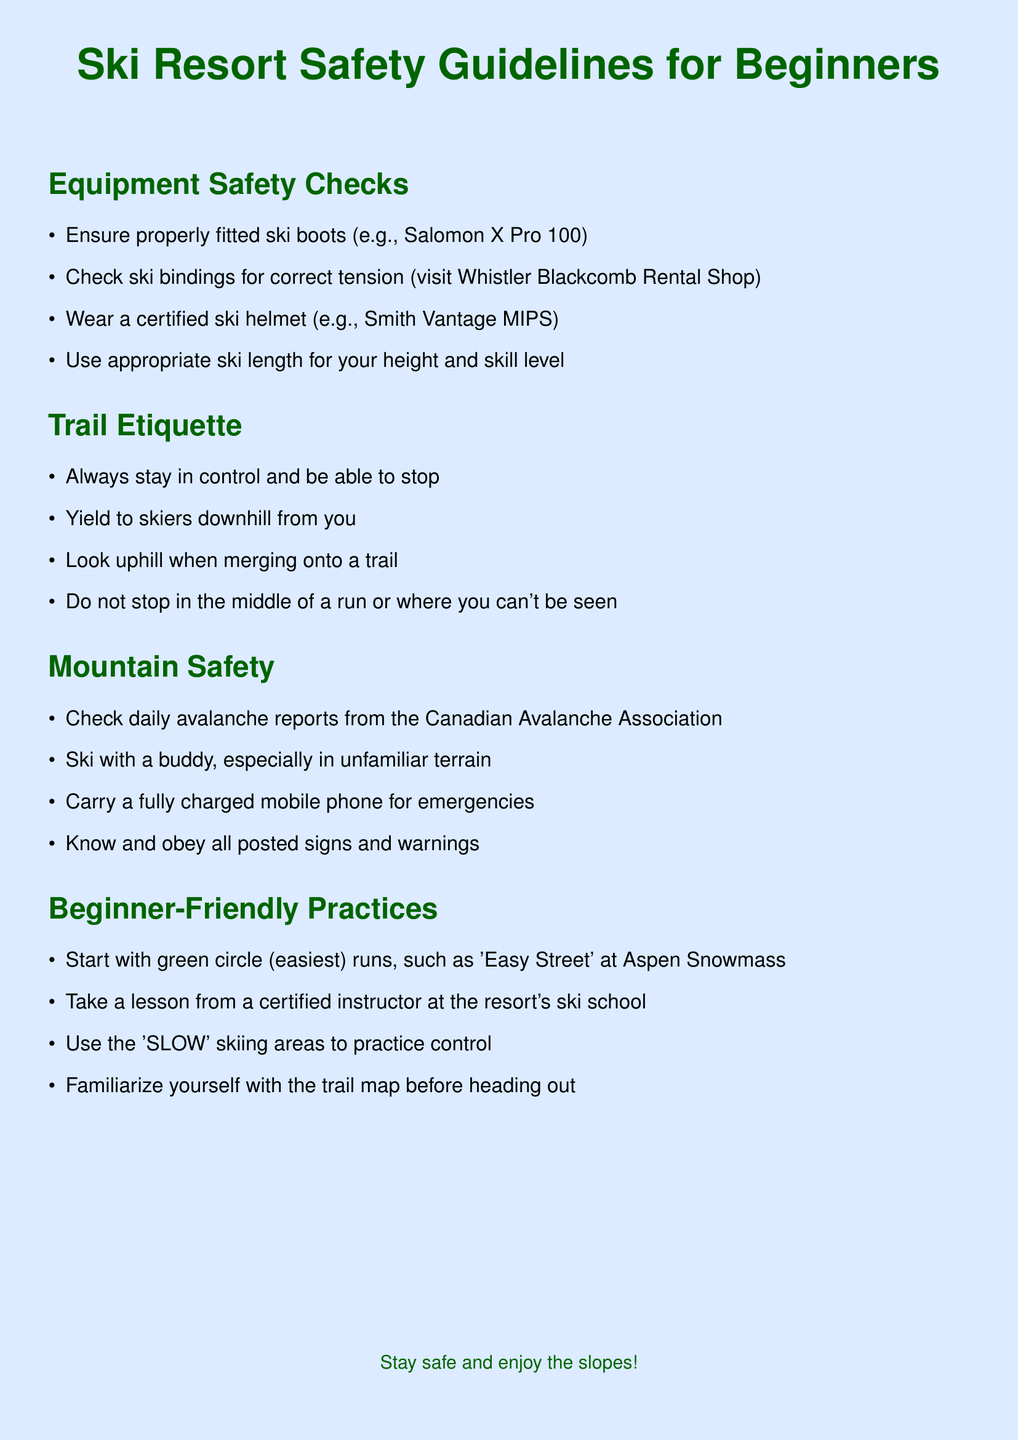What do you need to ensure for ski boots? The document states that you need to ensure properly fitted ski boots.
Answer: Properly fitted ski boots What equipment is recommended for trail merging? The document mentions to look uphill when merging onto a trail.
Answer: Look uphill What should you check daily for mountain safety? The daily check refers to avalanche reports from the Canadian Avalanche Association.
Answer: Avalanche reports Which ski runs should beginners start with? The document recommends starting with green circle (easiest) runs.
Answer: Green circle runs What type of helmet should you wear? The document states to wear a certified ski helmet.
Answer: Certified ski helmet How can you practice control while skiing? The document advises using the 'SLOW' skiing areas to practice control.
Answer: 'SLOW' skiing areas What is the main guideline for yielding? You should yield to skiers downhill from you.
Answer: Yield to skiers downhill What is advised to carry for emergencies? The document emphasizes carrying a fully charged mobile phone for emergencies.
Answer: Fully charged mobile phone 